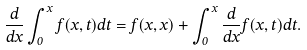Convert formula to latex. <formula><loc_0><loc_0><loc_500><loc_500>\frac { d } { d x } \int _ { 0 } ^ { x } f ( x , t ) d t = f ( x , x ) + \int _ { 0 } ^ { x } \frac { d } { d x } f ( x , t ) d t .</formula> 